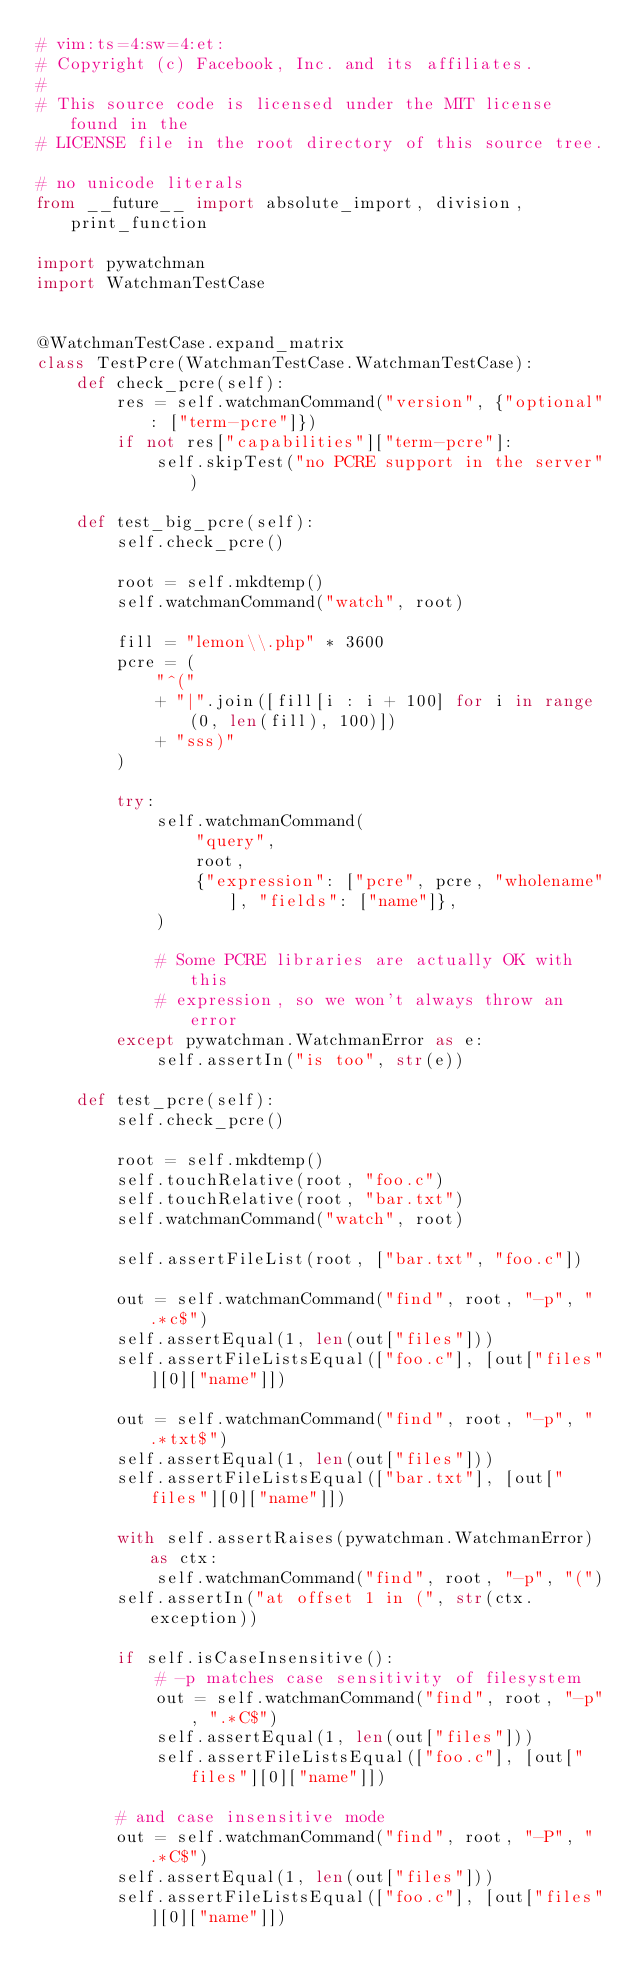<code> <loc_0><loc_0><loc_500><loc_500><_Python_># vim:ts=4:sw=4:et:
# Copyright (c) Facebook, Inc. and its affiliates.
#
# This source code is licensed under the MIT license found in the
# LICENSE file in the root directory of this source tree.

# no unicode literals
from __future__ import absolute_import, division, print_function

import pywatchman
import WatchmanTestCase


@WatchmanTestCase.expand_matrix
class TestPcre(WatchmanTestCase.WatchmanTestCase):
    def check_pcre(self):
        res = self.watchmanCommand("version", {"optional": ["term-pcre"]})
        if not res["capabilities"]["term-pcre"]:
            self.skipTest("no PCRE support in the server")

    def test_big_pcre(self):
        self.check_pcre()

        root = self.mkdtemp()
        self.watchmanCommand("watch", root)

        fill = "lemon\\.php" * 3600
        pcre = (
            "^("
            + "|".join([fill[i : i + 100] for i in range(0, len(fill), 100)])
            + "sss)"
        )

        try:
            self.watchmanCommand(
                "query",
                root,
                {"expression": ["pcre", pcre, "wholename"], "fields": ["name"]},
            )

            # Some PCRE libraries are actually OK with this
            # expression, so we won't always throw an error
        except pywatchman.WatchmanError as e:
            self.assertIn("is too", str(e))

    def test_pcre(self):
        self.check_pcre()

        root = self.mkdtemp()
        self.touchRelative(root, "foo.c")
        self.touchRelative(root, "bar.txt")
        self.watchmanCommand("watch", root)

        self.assertFileList(root, ["bar.txt", "foo.c"])

        out = self.watchmanCommand("find", root, "-p", ".*c$")
        self.assertEqual(1, len(out["files"]))
        self.assertFileListsEqual(["foo.c"], [out["files"][0]["name"]])

        out = self.watchmanCommand("find", root, "-p", ".*txt$")
        self.assertEqual(1, len(out["files"]))
        self.assertFileListsEqual(["bar.txt"], [out["files"][0]["name"]])

        with self.assertRaises(pywatchman.WatchmanError) as ctx:
            self.watchmanCommand("find", root, "-p", "(")
        self.assertIn("at offset 1 in (", str(ctx.exception))

        if self.isCaseInsensitive():
            # -p matches case sensitivity of filesystem
            out = self.watchmanCommand("find", root, "-p", ".*C$")
            self.assertEqual(1, len(out["files"]))
            self.assertFileListsEqual(["foo.c"], [out["files"][0]["name"]])

        # and case insensitive mode
        out = self.watchmanCommand("find", root, "-P", ".*C$")
        self.assertEqual(1, len(out["files"]))
        self.assertFileListsEqual(["foo.c"], [out["files"][0]["name"]])
</code> 